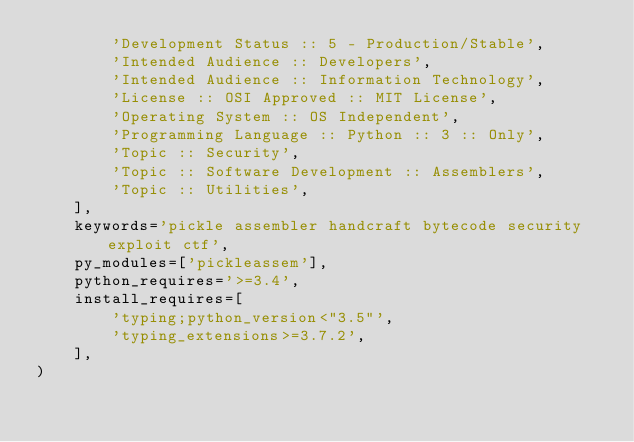<code> <loc_0><loc_0><loc_500><loc_500><_Python_>        'Development Status :: 5 - Production/Stable',
        'Intended Audience :: Developers',
        'Intended Audience :: Information Technology',
        'License :: OSI Approved :: MIT License',
        'Operating System :: OS Independent',
        'Programming Language :: Python :: 3 :: Only',
        'Topic :: Security',
        'Topic :: Software Development :: Assemblers',
        'Topic :: Utilities',
    ],
    keywords='pickle assembler handcraft bytecode security exploit ctf',
    py_modules=['pickleassem'],
    python_requires='>=3.4',
    install_requires=[
        'typing;python_version<"3.5"',
        'typing_extensions>=3.7.2',
    ],
)
</code> 